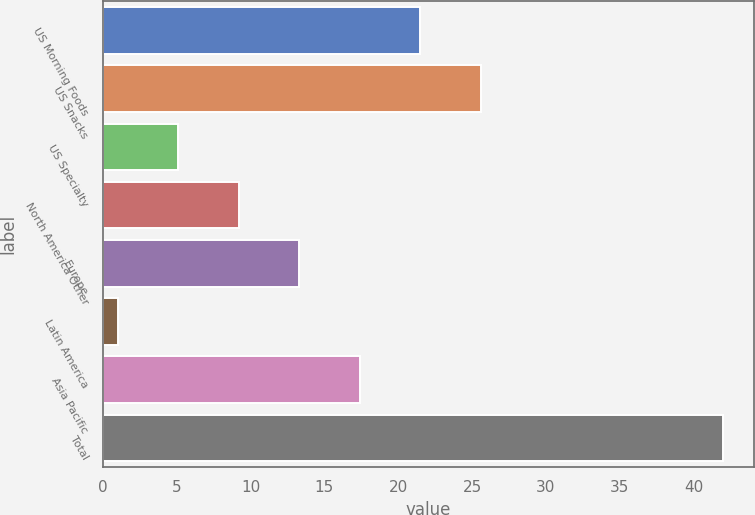<chart> <loc_0><loc_0><loc_500><loc_500><bar_chart><fcel>US Morning Foods<fcel>US Snacks<fcel>US Specialty<fcel>North America Other<fcel>Europe<fcel>Latin America<fcel>Asia Pacific<fcel>Total<nl><fcel>21.5<fcel>25.6<fcel>5.1<fcel>9.2<fcel>13.3<fcel>1<fcel>17.4<fcel>42<nl></chart> 